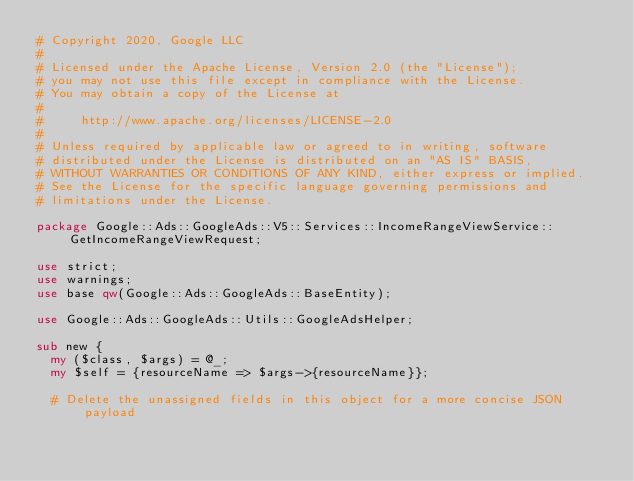Convert code to text. <code><loc_0><loc_0><loc_500><loc_500><_Perl_># Copyright 2020, Google LLC
#
# Licensed under the Apache License, Version 2.0 (the "License");
# you may not use this file except in compliance with the License.
# You may obtain a copy of the License at
#
#     http://www.apache.org/licenses/LICENSE-2.0
#
# Unless required by applicable law or agreed to in writing, software
# distributed under the License is distributed on an "AS IS" BASIS,
# WITHOUT WARRANTIES OR CONDITIONS OF ANY KIND, either express or implied.
# See the License for the specific language governing permissions and
# limitations under the License.

package Google::Ads::GoogleAds::V5::Services::IncomeRangeViewService::GetIncomeRangeViewRequest;

use strict;
use warnings;
use base qw(Google::Ads::GoogleAds::BaseEntity);

use Google::Ads::GoogleAds::Utils::GoogleAdsHelper;

sub new {
  my ($class, $args) = @_;
  my $self = {resourceName => $args->{resourceName}};

  # Delete the unassigned fields in this object for a more concise JSON payload</code> 